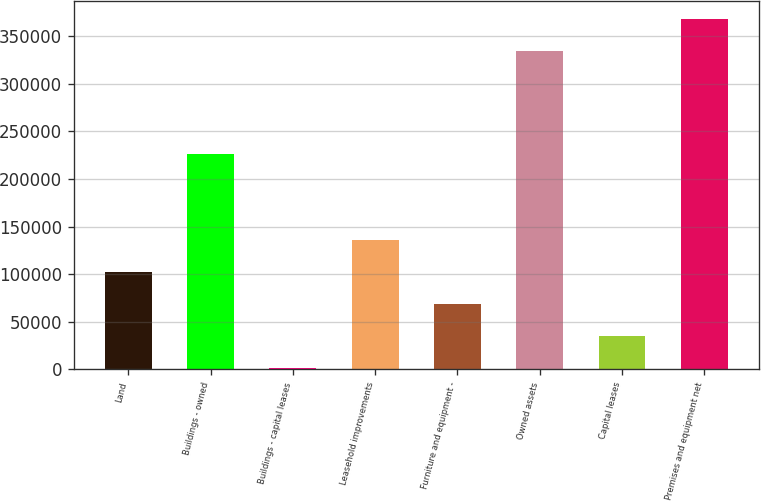<chart> <loc_0><loc_0><loc_500><loc_500><bar_chart><fcel>Land<fcel>Buildings - owned<fcel>Buildings - capital leases<fcel>Leasehold improvements<fcel>Furniture and equipment -<fcel>Owned assets<fcel>Capital leases<fcel>Premises and equipment net<nl><fcel>102253<fcel>225828<fcel>1598<fcel>135805<fcel>68701.4<fcel>334690<fcel>35149.7<fcel>368241<nl></chart> 